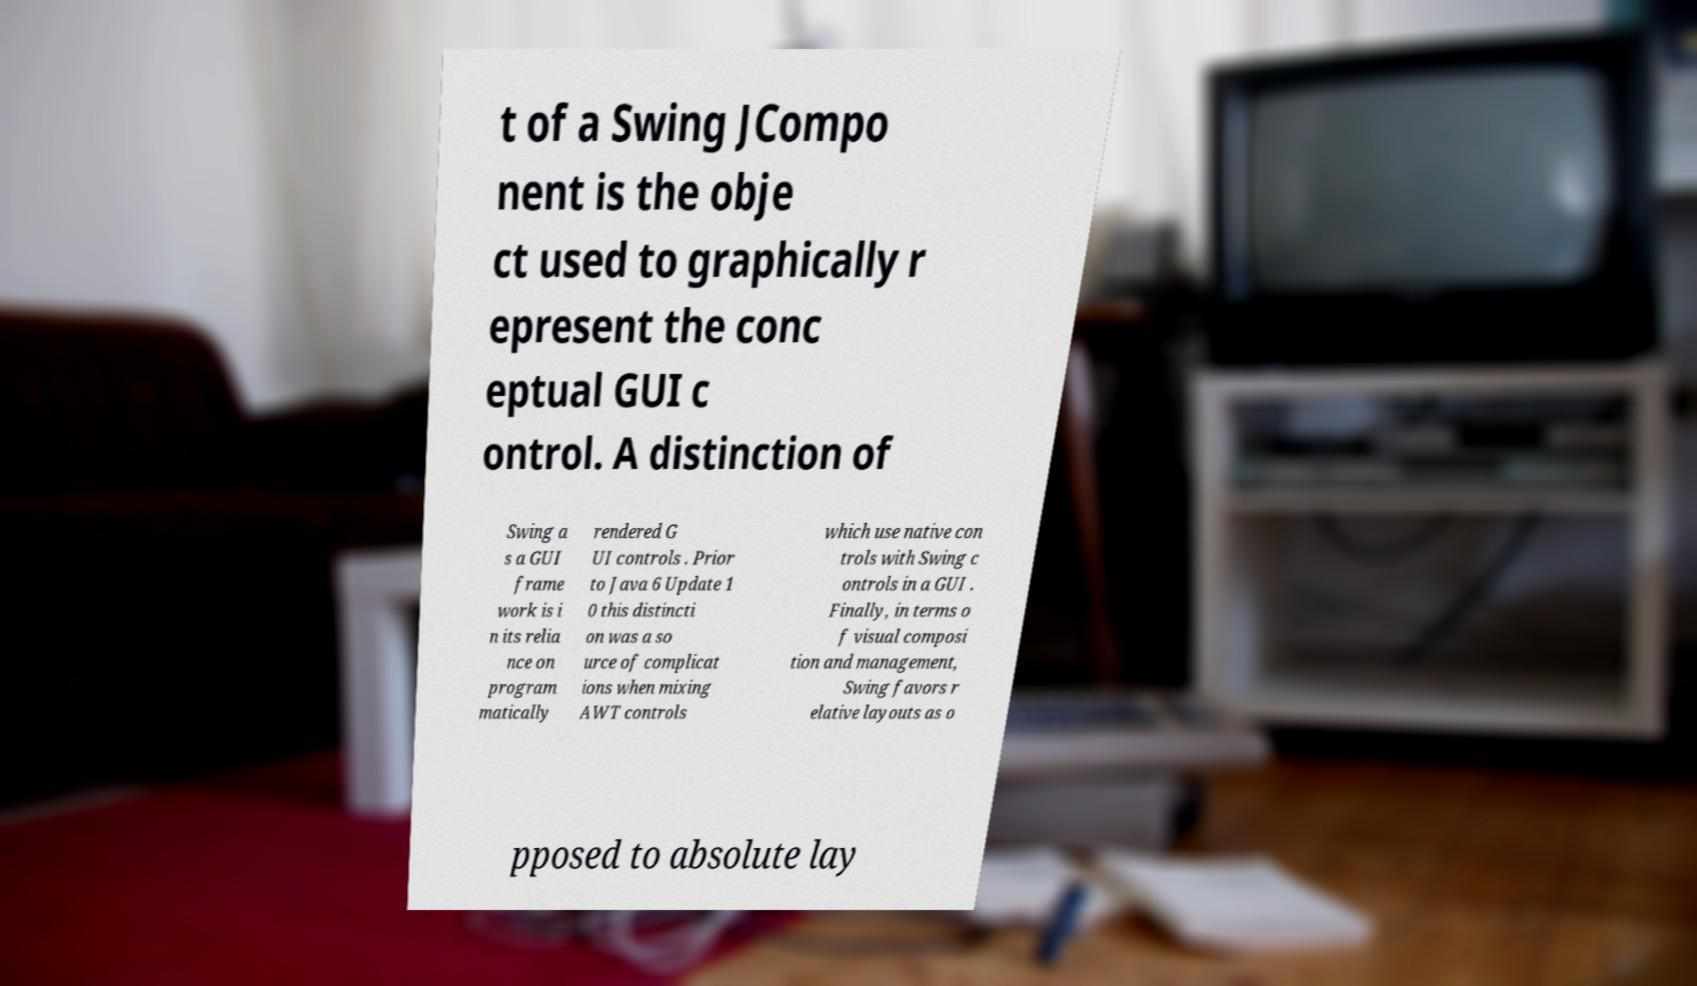For documentation purposes, I need the text within this image transcribed. Could you provide that? t of a Swing JCompo nent is the obje ct used to graphically r epresent the conc eptual GUI c ontrol. A distinction of Swing a s a GUI frame work is i n its relia nce on program matically rendered G UI controls . Prior to Java 6 Update 1 0 this distincti on was a so urce of complicat ions when mixing AWT controls which use native con trols with Swing c ontrols in a GUI . Finally, in terms o f visual composi tion and management, Swing favors r elative layouts as o pposed to absolute lay 